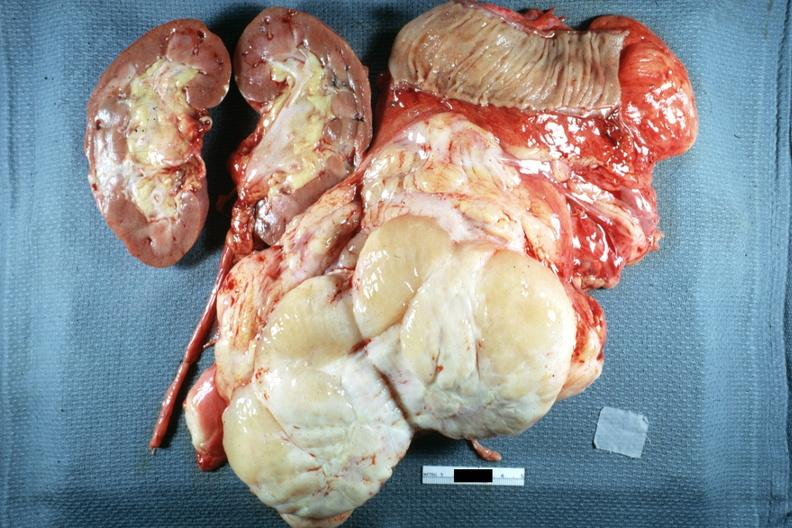what does surface show?
Answer the question using a single word or phrase. Typical fish flesh and yellow sarcoma 